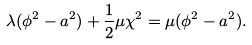Convert formula to latex. <formula><loc_0><loc_0><loc_500><loc_500>\lambda ( \phi ^ { 2 } - a ^ { 2 } ) + \frac { 1 } { 2 } \mu \chi ^ { 2 } = \mu ( \phi ^ { 2 } - a ^ { 2 } ) .</formula> 